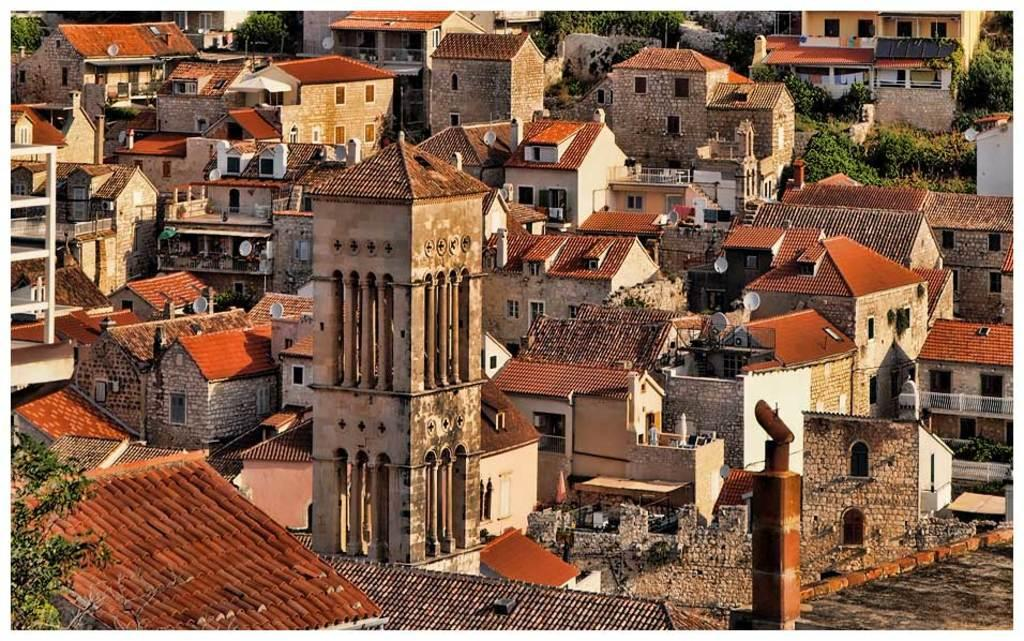What type of structures can be seen in the image? There are buildings in the image. What features do the buildings have? The buildings have doors and windows. What else can be seen in the image besides the buildings? There are trees in the image. What type of weather condition is depicted in the image involving sleet? There is no mention of sleet or any weather condition in the image; it only shows buildings and trees. Can you see any chickens in the image? There are no chickens present in the image. 